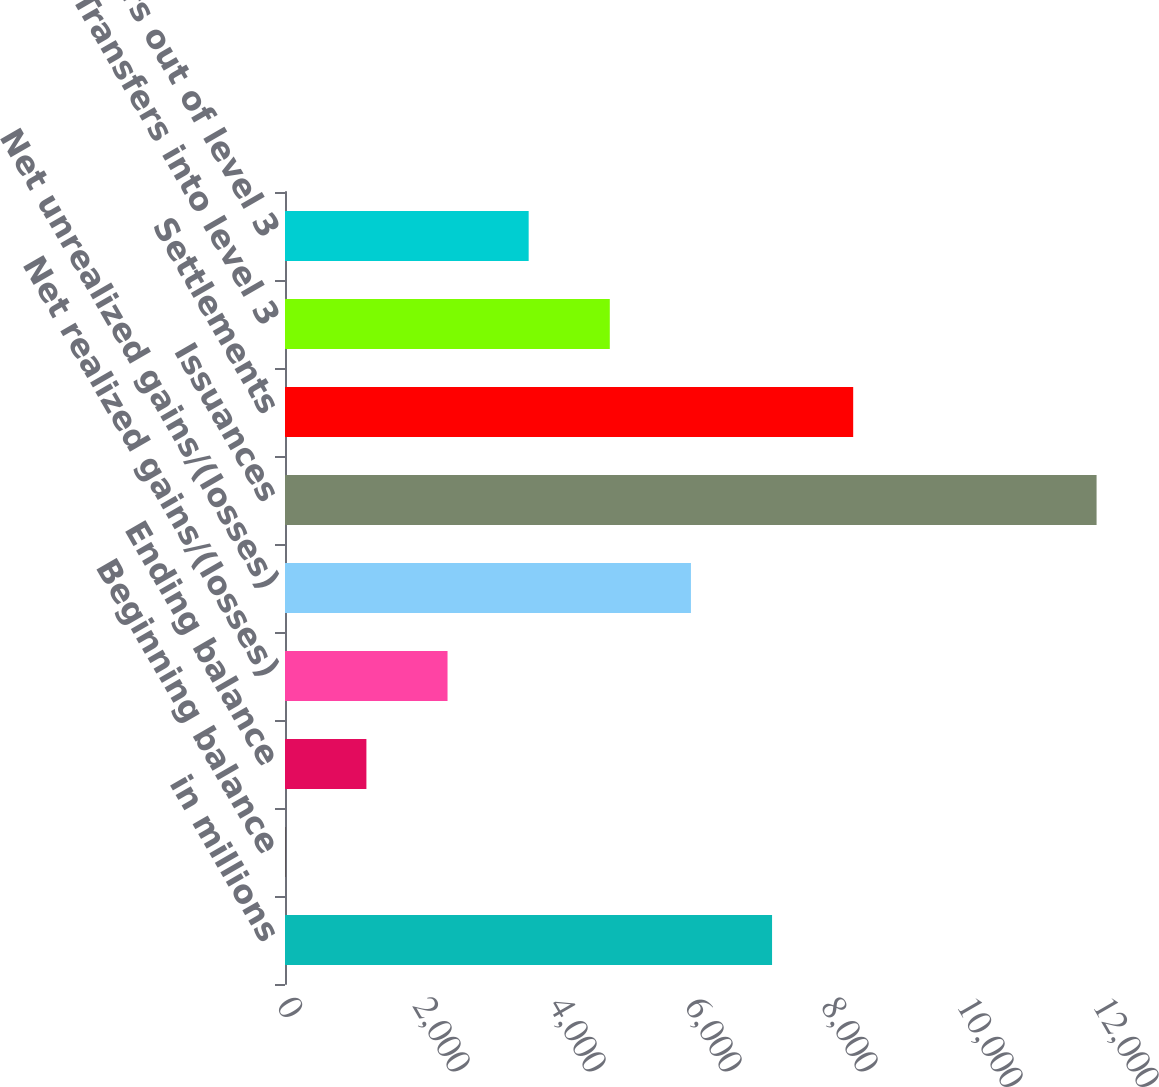Convert chart. <chart><loc_0><loc_0><loc_500><loc_500><bar_chart><fcel>in millions<fcel>Beginning balance<fcel>Ending balance<fcel>Net realized gains/(losses)<fcel>Net unrealized gains/(losses)<fcel>Issuances<fcel>Settlements<fcel>Transfers into level 3<fcel>Transfers out of level 3<nl><fcel>7162.6<fcel>4<fcel>1197.1<fcel>2390.2<fcel>5969.5<fcel>11935<fcel>8355.7<fcel>4776.4<fcel>3583.3<nl></chart> 